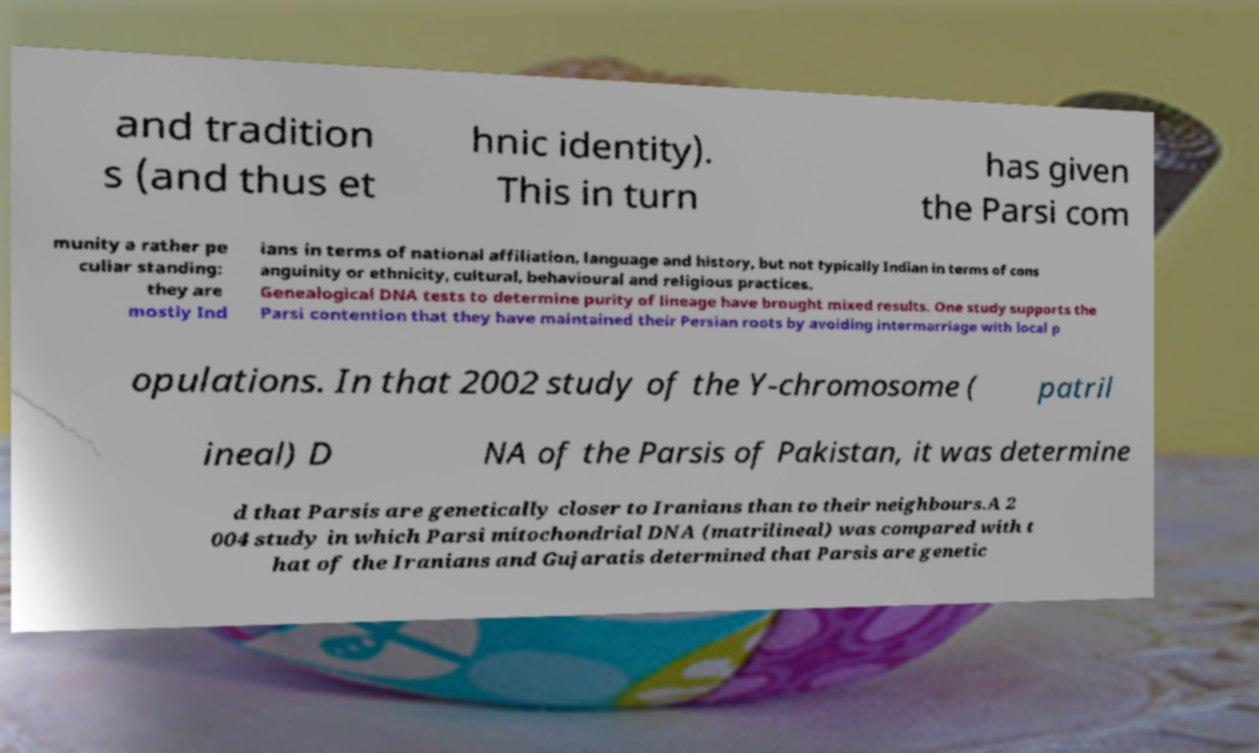What messages or text are displayed in this image? I need them in a readable, typed format. and tradition s (and thus et hnic identity). This in turn has given the Parsi com munity a rather pe culiar standing: they are mostly Ind ians in terms of national affiliation, language and history, but not typically Indian in terms of cons anguinity or ethnicity, cultural, behavioural and religious practices. Genealogical DNA tests to determine purity of lineage have brought mixed results. One study supports the Parsi contention that they have maintained their Persian roots by avoiding intermarriage with local p opulations. In that 2002 study of the Y-chromosome ( patril ineal) D NA of the Parsis of Pakistan, it was determine d that Parsis are genetically closer to Iranians than to their neighbours.A 2 004 study in which Parsi mitochondrial DNA (matrilineal) was compared with t hat of the Iranians and Gujaratis determined that Parsis are genetic 